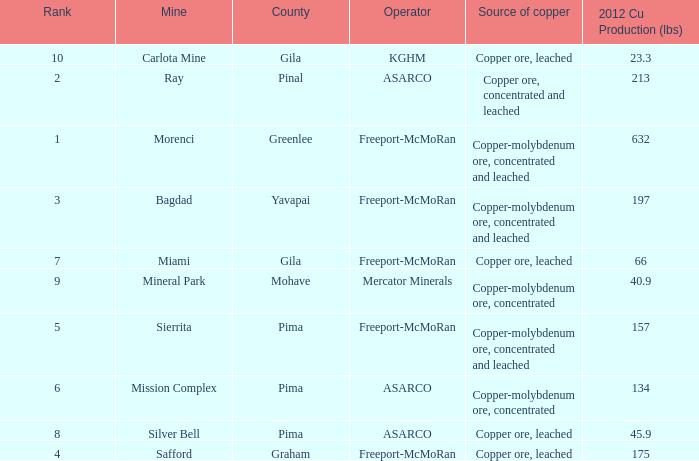What's the name of the operator who has the mission complex mine and has a 2012 Cu Production (lbs) larger than 23.3? ASARCO. 